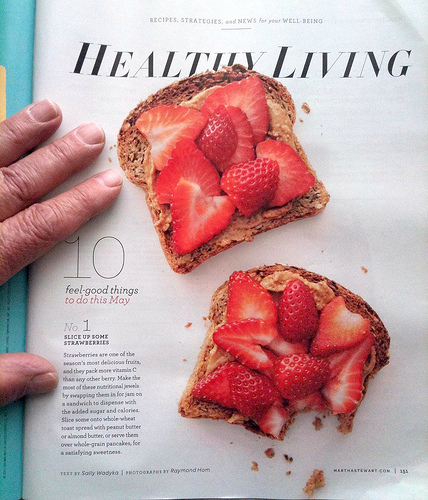<image>
Is there a toast in front of the strawberry? No. The toast is not in front of the strawberry. The spatial positioning shows a different relationship between these objects. 